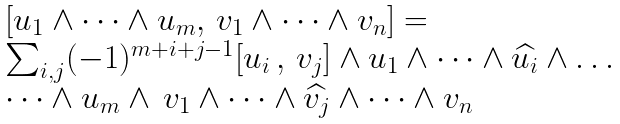<formula> <loc_0><loc_0><loc_500><loc_500>\begin{array} { l } [ u _ { 1 } \wedge \dots \wedge u _ { m } , \, v _ { 1 } \wedge \dots \wedge v _ { n } ] = \\ \sum _ { i , j } ( - 1 ) ^ { m + i + j - 1 } [ u _ { i } \, , \, v _ { j } ] \wedge u _ { 1 } \wedge \dots \wedge \widehat { u _ { i } } \wedge \dots \\ \dots \wedge u _ { m } \wedge \, v _ { 1 } \wedge \dots \wedge \widehat { v _ { j } } \wedge \dots \wedge v _ { n } \end{array}</formula> 